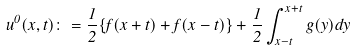Convert formula to latex. <formula><loc_0><loc_0><loc_500><loc_500>u ^ { 0 } ( x , t ) \colon = \frac { 1 } { 2 } \{ f ( x + t ) + f ( x - t ) \} + \frac { 1 } { 2 } \int _ { x - t } ^ { x + t } g ( y ) d y</formula> 